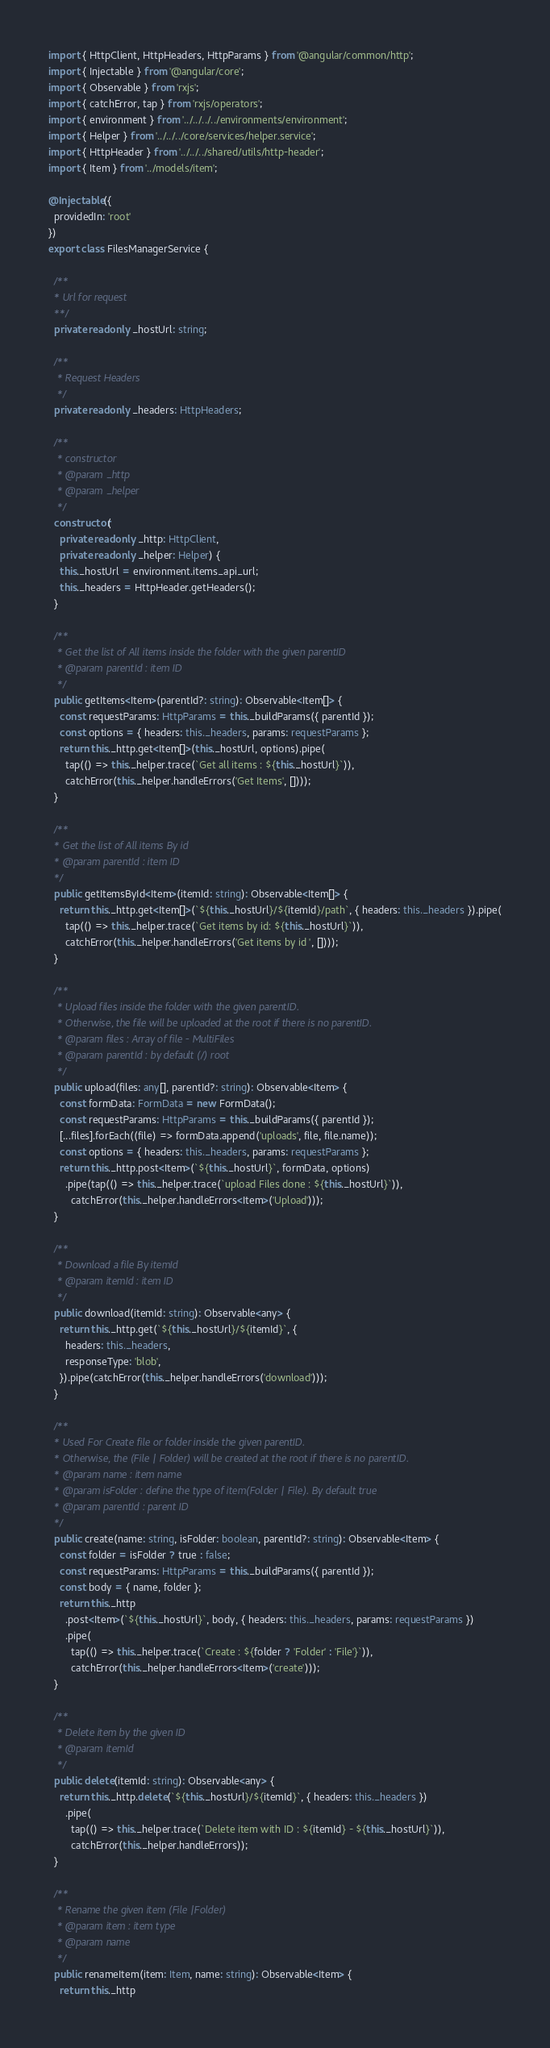<code> <loc_0><loc_0><loc_500><loc_500><_TypeScript_>import { HttpClient, HttpHeaders, HttpParams } from '@angular/common/http';
import { Injectable } from '@angular/core';
import { Observable } from 'rxjs';
import { catchError, tap } from 'rxjs/operators';
import { environment } from '../../../../environments/environment';
import { Helper } from '../../../core/services/helper.service';
import { HttpHeader } from '../../../shared/utils/http-header';
import { Item } from '../models/item';

@Injectable({
  providedIn: 'root'
})
export class FilesManagerService {

  /**
  * Url for request
  **/
  private readonly _hostUrl: string;

  /**
   * Request Headers
   */
  private readonly _headers: HttpHeaders;

  /**
   * constructor
   * @param _http
   * @param _helper
   */
  constructor(
    private readonly _http: HttpClient,
    private readonly _helper: Helper) {
    this._hostUrl = environment.items_api_url;
    this._headers = HttpHeader.getHeaders();
  }

  /**
   * Get the list of All items inside the folder with the given parentID
   * @param parentId : item ID
   */
  public getItems<Item>(parentId?: string): Observable<Item[]> {
    const requestParams: HttpParams = this._buildParams({ parentId });
    const options = { headers: this._headers, params: requestParams };
    return this._http.get<Item[]>(this._hostUrl, options).pipe(
      tap(() => this._helper.trace(`Get all items : ${this._hostUrl}`)),
      catchError(this._helper.handleErrors('Get Items', [])));
  }

  /**
  * Get the list of All items By id
  * @param parentId : item ID
  */
  public getItemsById<Item>(itemId: string): Observable<Item[]> {
    return this._http.get<Item[]>(`${this._hostUrl}/${itemId}/path`, { headers: this._headers }).pipe(
      tap(() => this._helper.trace(`Get items by id: ${this._hostUrl}`)),
      catchError(this._helper.handleErrors('Get items by id ', [])));
  }

  /**
   * Upload files inside the folder with the given parentID.
   * Otherwise, the file will be uploaded at the root if there is no parentID.
   * @param files : Array of file - MultiFiles
   * @param parentId : by default (/) root
   */
  public upload(files: any[], parentId?: string): Observable<Item> {
    const formData: FormData = new FormData();
    const requestParams: HttpParams = this._buildParams({ parentId });
    [...files].forEach((file) => formData.append('uploads', file, file.name));
    const options = { headers: this._headers, params: requestParams };
    return this._http.post<Item>(`${this._hostUrl}`, formData, options)
      .pipe(tap(() => this._helper.trace(`upload Files done : ${this._hostUrl}`)),
        catchError(this._helper.handleErrors<Item>('Upload')));
  }

  /**
   * Download a file By itemId
   * @param itemId : item ID
   */
  public download(itemId: string): Observable<any> {
    return this._http.get(`${this._hostUrl}/${itemId}`, {
      headers: this._headers,
      responseType: 'blob',
    }).pipe(catchError(this._helper.handleErrors('download')));
  }

  /**
  * Used For Create file or folder inside the given parentID.
  * Otherwise, the (File | Folder) will be created at the root if there is no parentID.
  * @param name : item name
  * @param isFolder : define the type of item(Folder | File). By default true
  * @param parentId : parent ID
  */
  public create(name: string, isFolder: boolean, parentId?: string): Observable<Item> {
    const folder = isFolder ? true : false;
    const requestParams: HttpParams = this._buildParams({ parentId });
    const body = { name, folder };
    return this._http
      .post<Item>(`${this._hostUrl}`, body, { headers: this._headers, params: requestParams })
      .pipe(
        tap(() => this._helper.trace(`Create : ${folder ? 'Folder' : 'File'}`)),
        catchError(this._helper.handleErrors<Item>('create')));
  }

  /**
   * Delete item by the given ID
   * @param itemId
   */
  public delete(itemId: string): Observable<any> {
    return this._http.delete(`${this._hostUrl}/${itemId}`, { headers: this._headers })
      .pipe(
        tap(() => this._helper.trace(`Delete item with ID : ${itemId} - ${this._hostUrl}`)),
        catchError(this._helper.handleErrors));
  }

  /**
   * Rename the given item (File |Folder)
   * @param item : item type
   * @param name
   */
  public renameItem(item: Item, name: string): Observable<Item> {
    return this._http</code> 